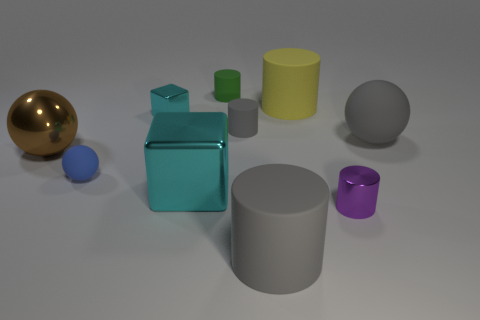Subtract all tiny spheres. How many spheres are left? 2 Subtract all cyan cubes. How many gray cylinders are left? 2 Subtract all blue spheres. How many spheres are left? 2 Subtract 2 cylinders. How many cylinders are left? 3 Add 3 cyan blocks. How many cyan blocks are left? 5 Add 5 tiny blue rubber things. How many tiny blue rubber things exist? 6 Subtract 1 gray spheres. How many objects are left? 9 Subtract all spheres. How many objects are left? 7 Subtract all green cylinders. Subtract all purple spheres. How many cylinders are left? 4 Subtract all tiny purple shiny objects. Subtract all matte objects. How many objects are left? 3 